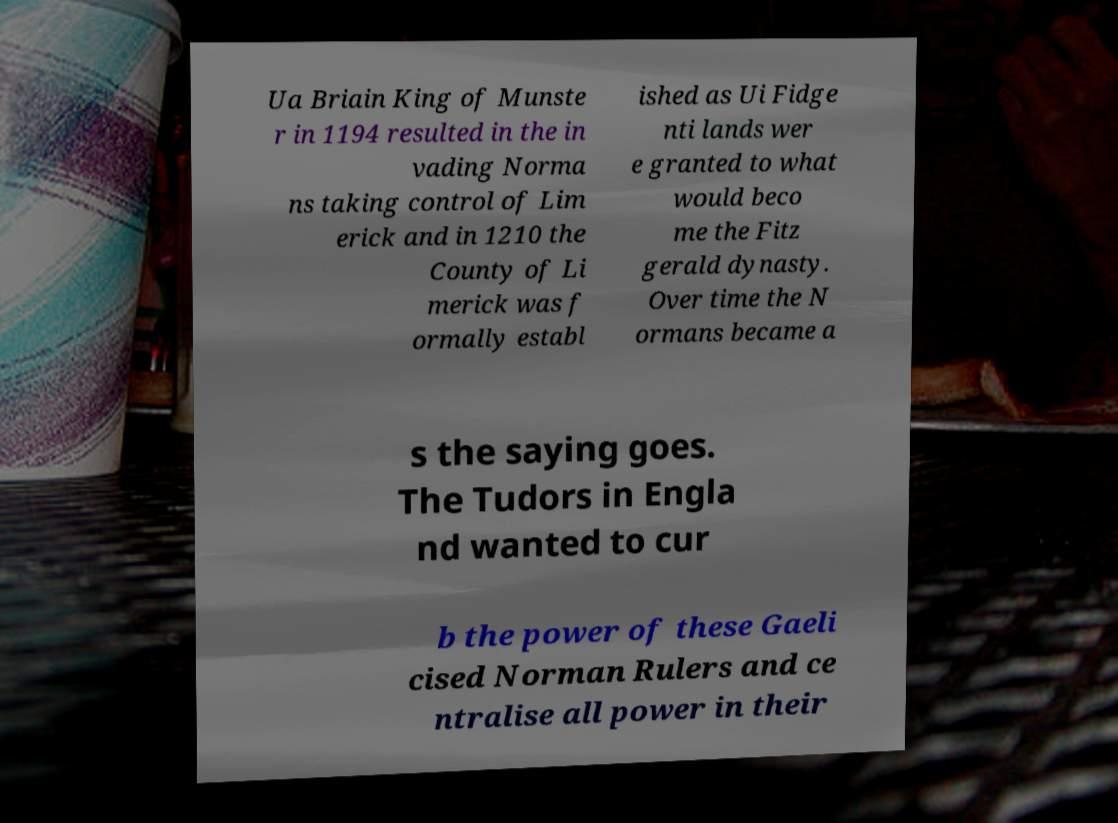What messages or text are displayed in this image? I need them in a readable, typed format. Ua Briain King of Munste r in 1194 resulted in the in vading Norma ns taking control of Lim erick and in 1210 the County of Li merick was f ormally establ ished as Ui Fidge nti lands wer e granted to what would beco me the Fitz gerald dynasty. Over time the N ormans became a s the saying goes. The Tudors in Engla nd wanted to cur b the power of these Gaeli cised Norman Rulers and ce ntralise all power in their 